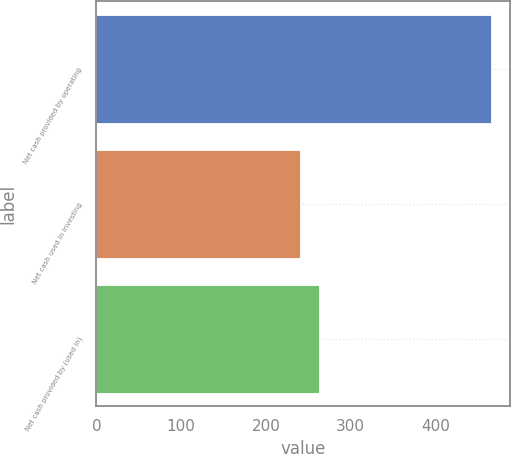<chart> <loc_0><loc_0><loc_500><loc_500><bar_chart><fcel>Net cash provided by operating<fcel>Net cash used in investing<fcel>Net cash provided by (used in)<nl><fcel>465.2<fcel>239.7<fcel>262.25<nl></chart> 